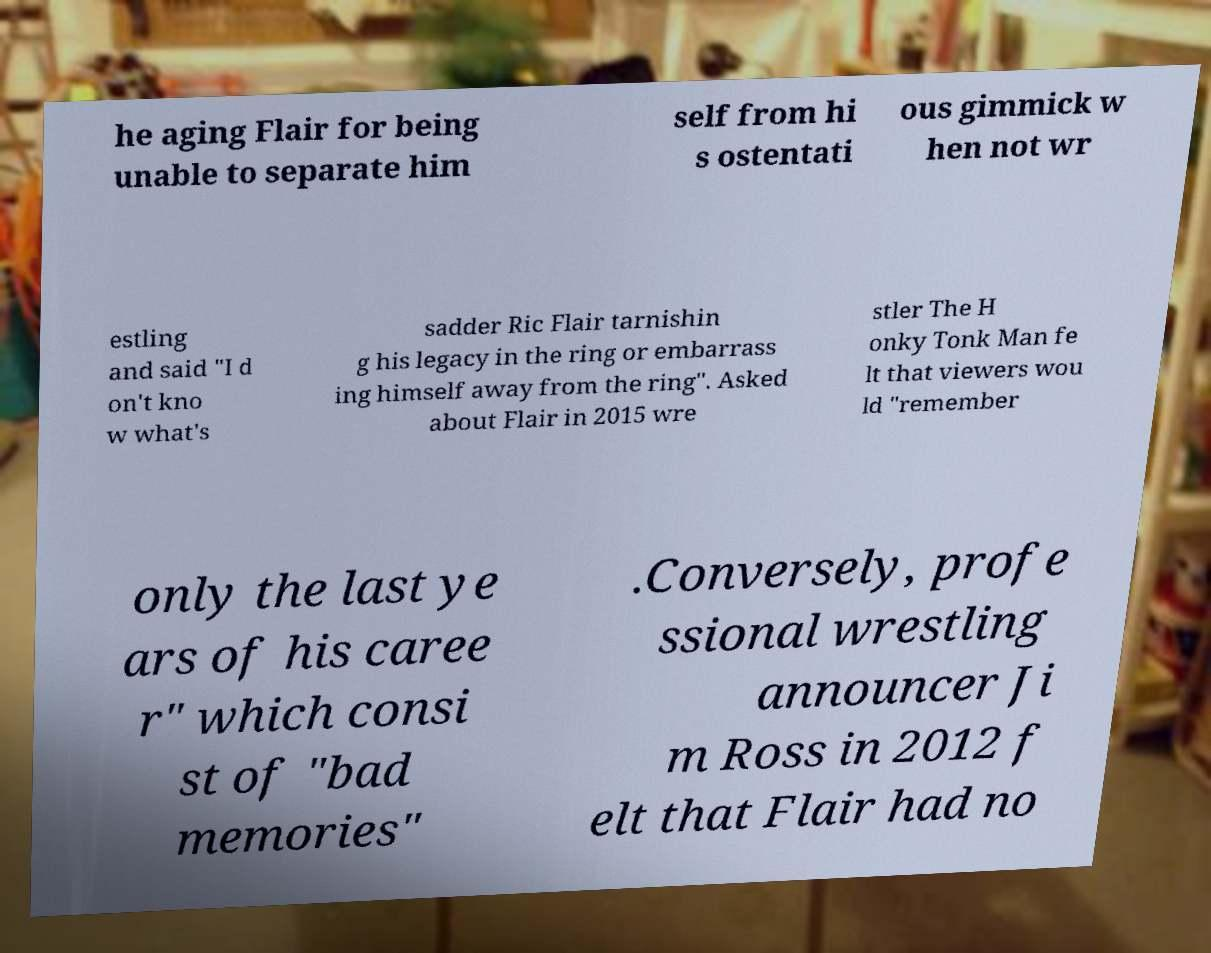Could you assist in decoding the text presented in this image and type it out clearly? he aging Flair for being unable to separate him self from hi s ostentati ous gimmick w hen not wr estling and said "I d on't kno w what's sadder Ric Flair tarnishin g his legacy in the ring or embarrass ing himself away from the ring". Asked about Flair in 2015 wre stler The H onky Tonk Man fe lt that viewers wou ld "remember only the last ye ars of his caree r" which consi st of "bad memories" .Conversely, profe ssional wrestling announcer Ji m Ross in 2012 f elt that Flair had no 